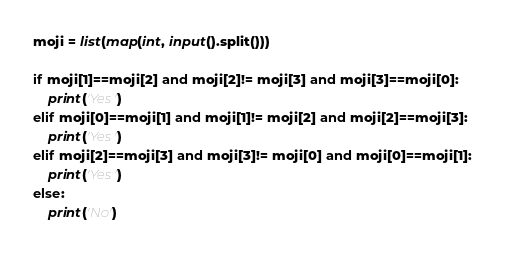<code> <loc_0><loc_0><loc_500><loc_500><_Python_>moji = list(map(int, input().split()))

if moji[1]==moji[2] and moji[2]!= moji[3] and moji[3]==moji[0]:
    print('Yes')
elif moji[0]==moji[1] and moji[1]!= moji[2] and moji[2]==moji[3]:
    print('Yes')
elif moji[2]==moji[3] and moji[3]!= moji[0] and moji[0]==moji[1]:
    print('Yes')
else:
    print('No')
</code> 